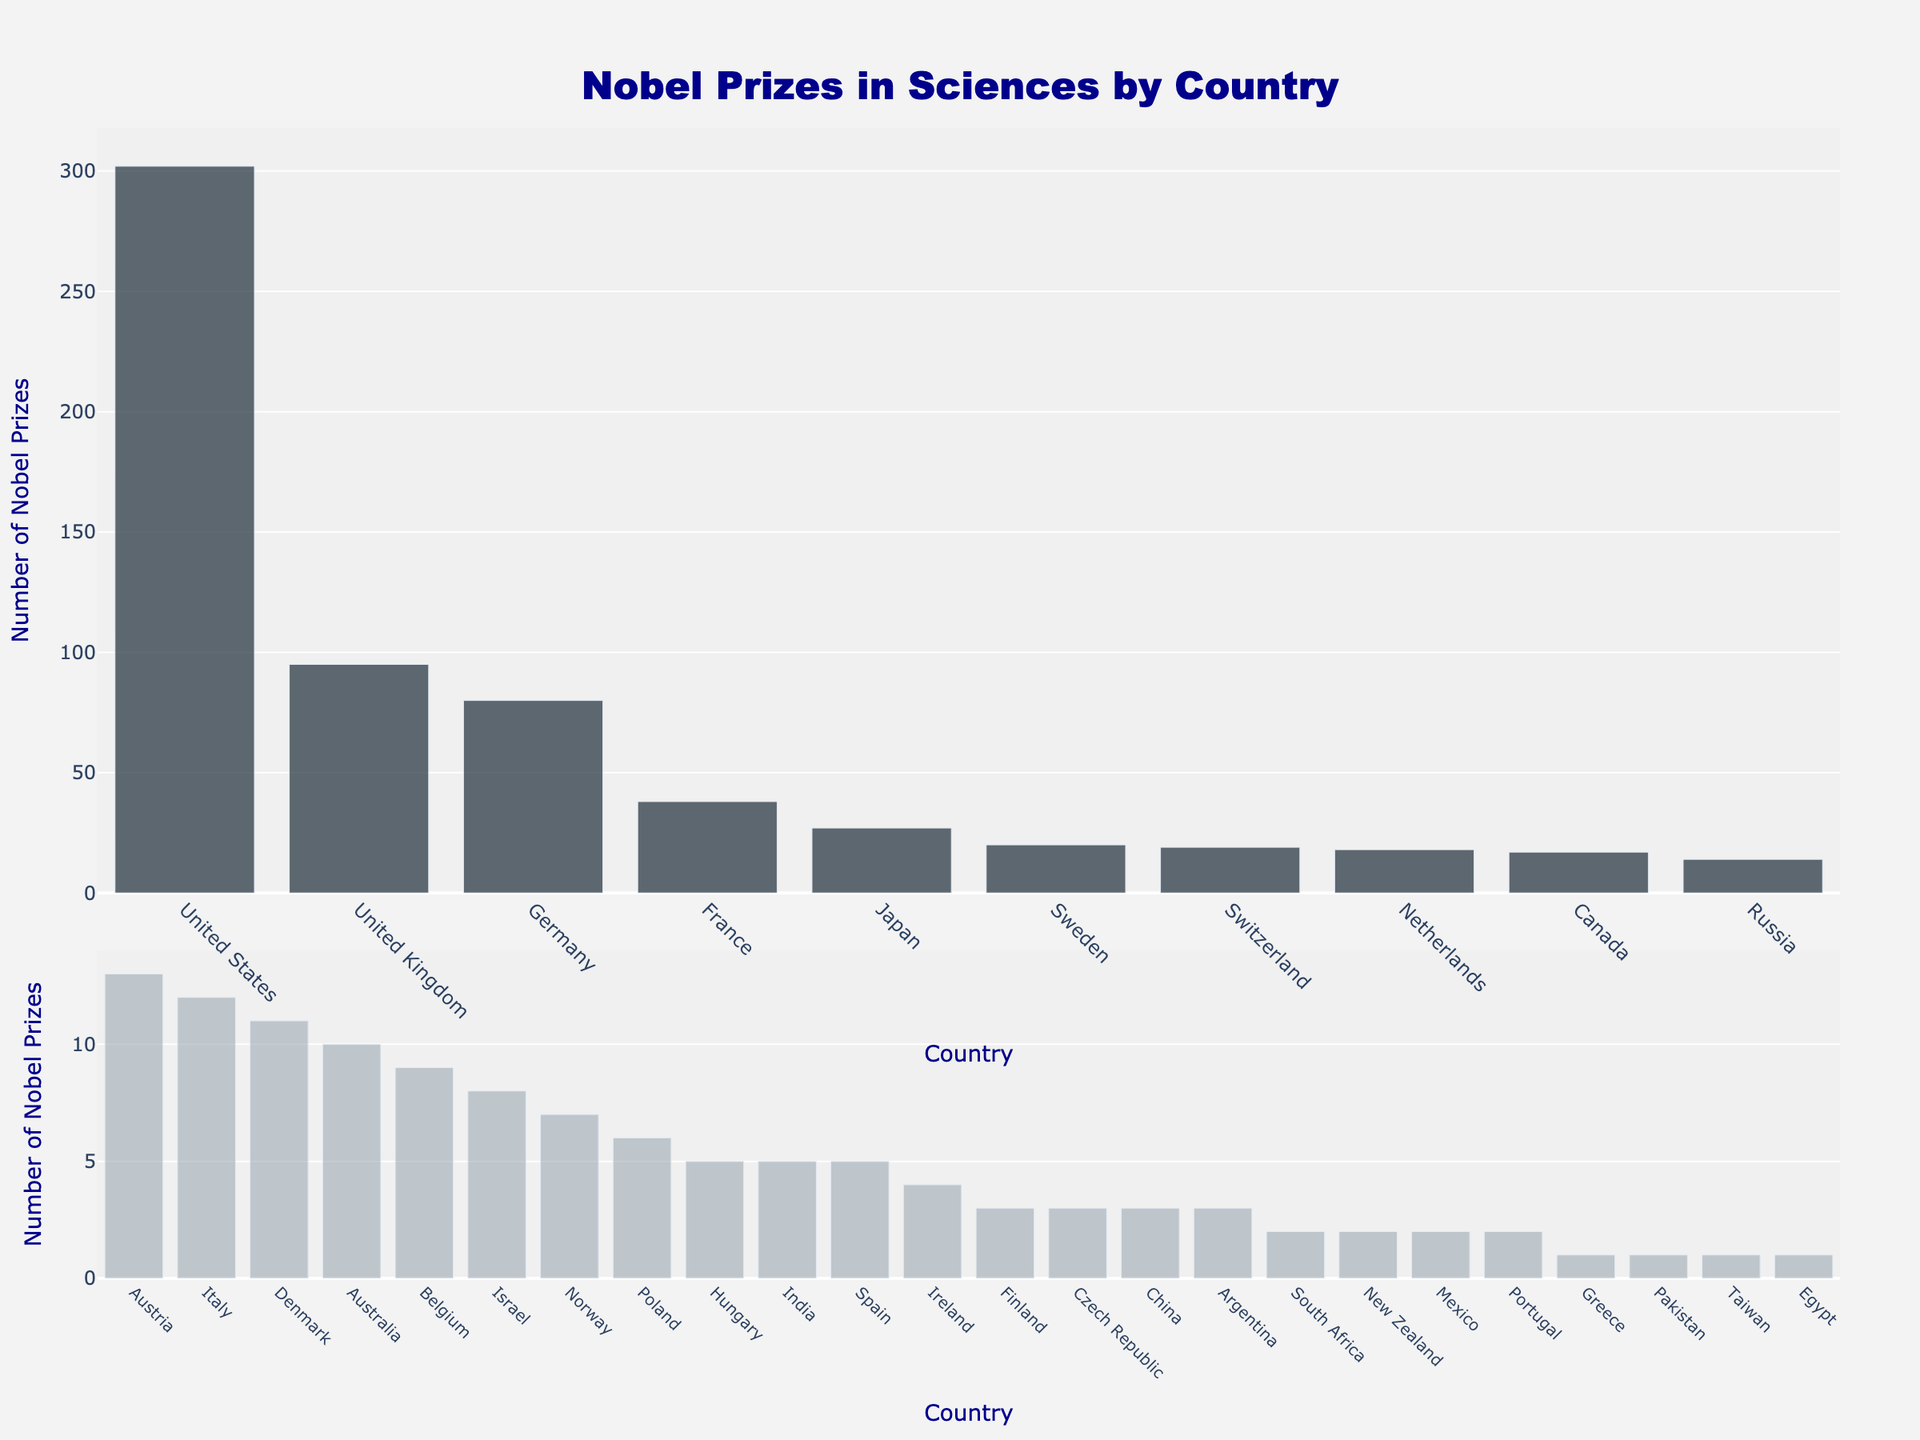Which country has the highest number of Nobel Prizes in Sciences? The figure shows the United States has the tallest bar in the top 10 countries section, indicating it has the highest number of Nobel Prizes in Sciences.
Answer: United States How many Nobel Prizes in Sciences have been awarded to the top 3 countries combined? To find the total for the top 3 countries, sum the values for the United States (302), United Kingdom (95), and Germany (80). Hence, 302 + 95 + 80 = 477.
Answer: 477 What is the difference in the number of Nobel Prizes in Sciences between the United Kingdom and France? Subtract the number of Nobel Prizes in Sciences of France (38) from the United Kingdom (95). Therefore, 95 - 38 = 57.
Answer: 57 Which country ranks fourth in terms of the number of Nobel Prizes in Sciences? The fourth tallest bar in the figure belongs to France.
Answer: France How many countries have been awarded fewer than 10 Nobel Prizes in Sciences? Look at the bars in the lower section; count the countries with Nobel Prizes lower than 10. They are Belgium (9), Israel (8), Norway (7), Poland (6), Hungary (5), India (5), Spain (5), Ireland (4), Finland (3), Czech Republic (3), China (3), Argentina (3), South Africa (2), New Zealand (2), Mexico (2), Portugal (2), Greece (1), Pakistan (1), Taiwan (1), and Egypt (1). This sums up to 20 countries.
Answer: 20 What is the average number of Nobel Prizes in Sciences for the top 5 countries? Calculate the average for the top 5 countries: United States (302), United Kingdom (95), Germany (80), France (38), and Japan (27). Sum these values and divide by 5. Hence, (302 + 95 + 80 + 38 + 27) / 5 = 542 / 5 = 108.4.
Answer: 108.4 Which country among the "Others" category has the highest number of Nobel Prizes in Sciences? In the second section of the figure, the tallest bar among the "Others" belongs to Austria.
Answer: Austria Which countries have an equal number of Nobel Prizes in Sciences, and what is that number? From the visual, Hungary, India, and Spain all have bars of the same height indicating they each have 5 Nobel Prizes in Sciences.
Answer: Hungary, India, Spain; 5 What is the total number of Nobel Prizes in Sciences for countries that have exactly 3 prizes? Add the number of Nobel Prizes for Finland, Czech Republic, China, and Argentina, each having 3 Nobel Prizes. Therefore, 3 + 3 + 3 + 3 = 12.
Answer: 12 